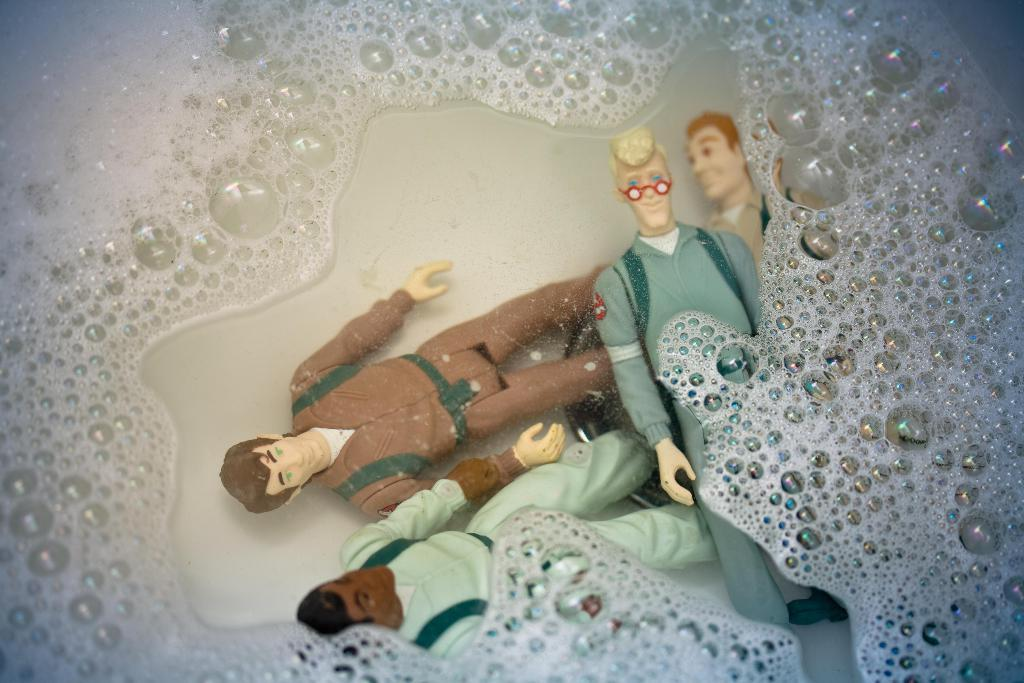What is in the water in the sink? There are miniatures in the water in the sink. What can be observed on the surface of the water? There is foam on the surface of the water. What caused the beef to be present in the sink? There is no beef present in the image, so it is not possible to determine the cause of its presence. 